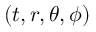Convert formula to latex. <formula><loc_0><loc_0><loc_500><loc_500>( t , r , \theta , \phi )</formula> 